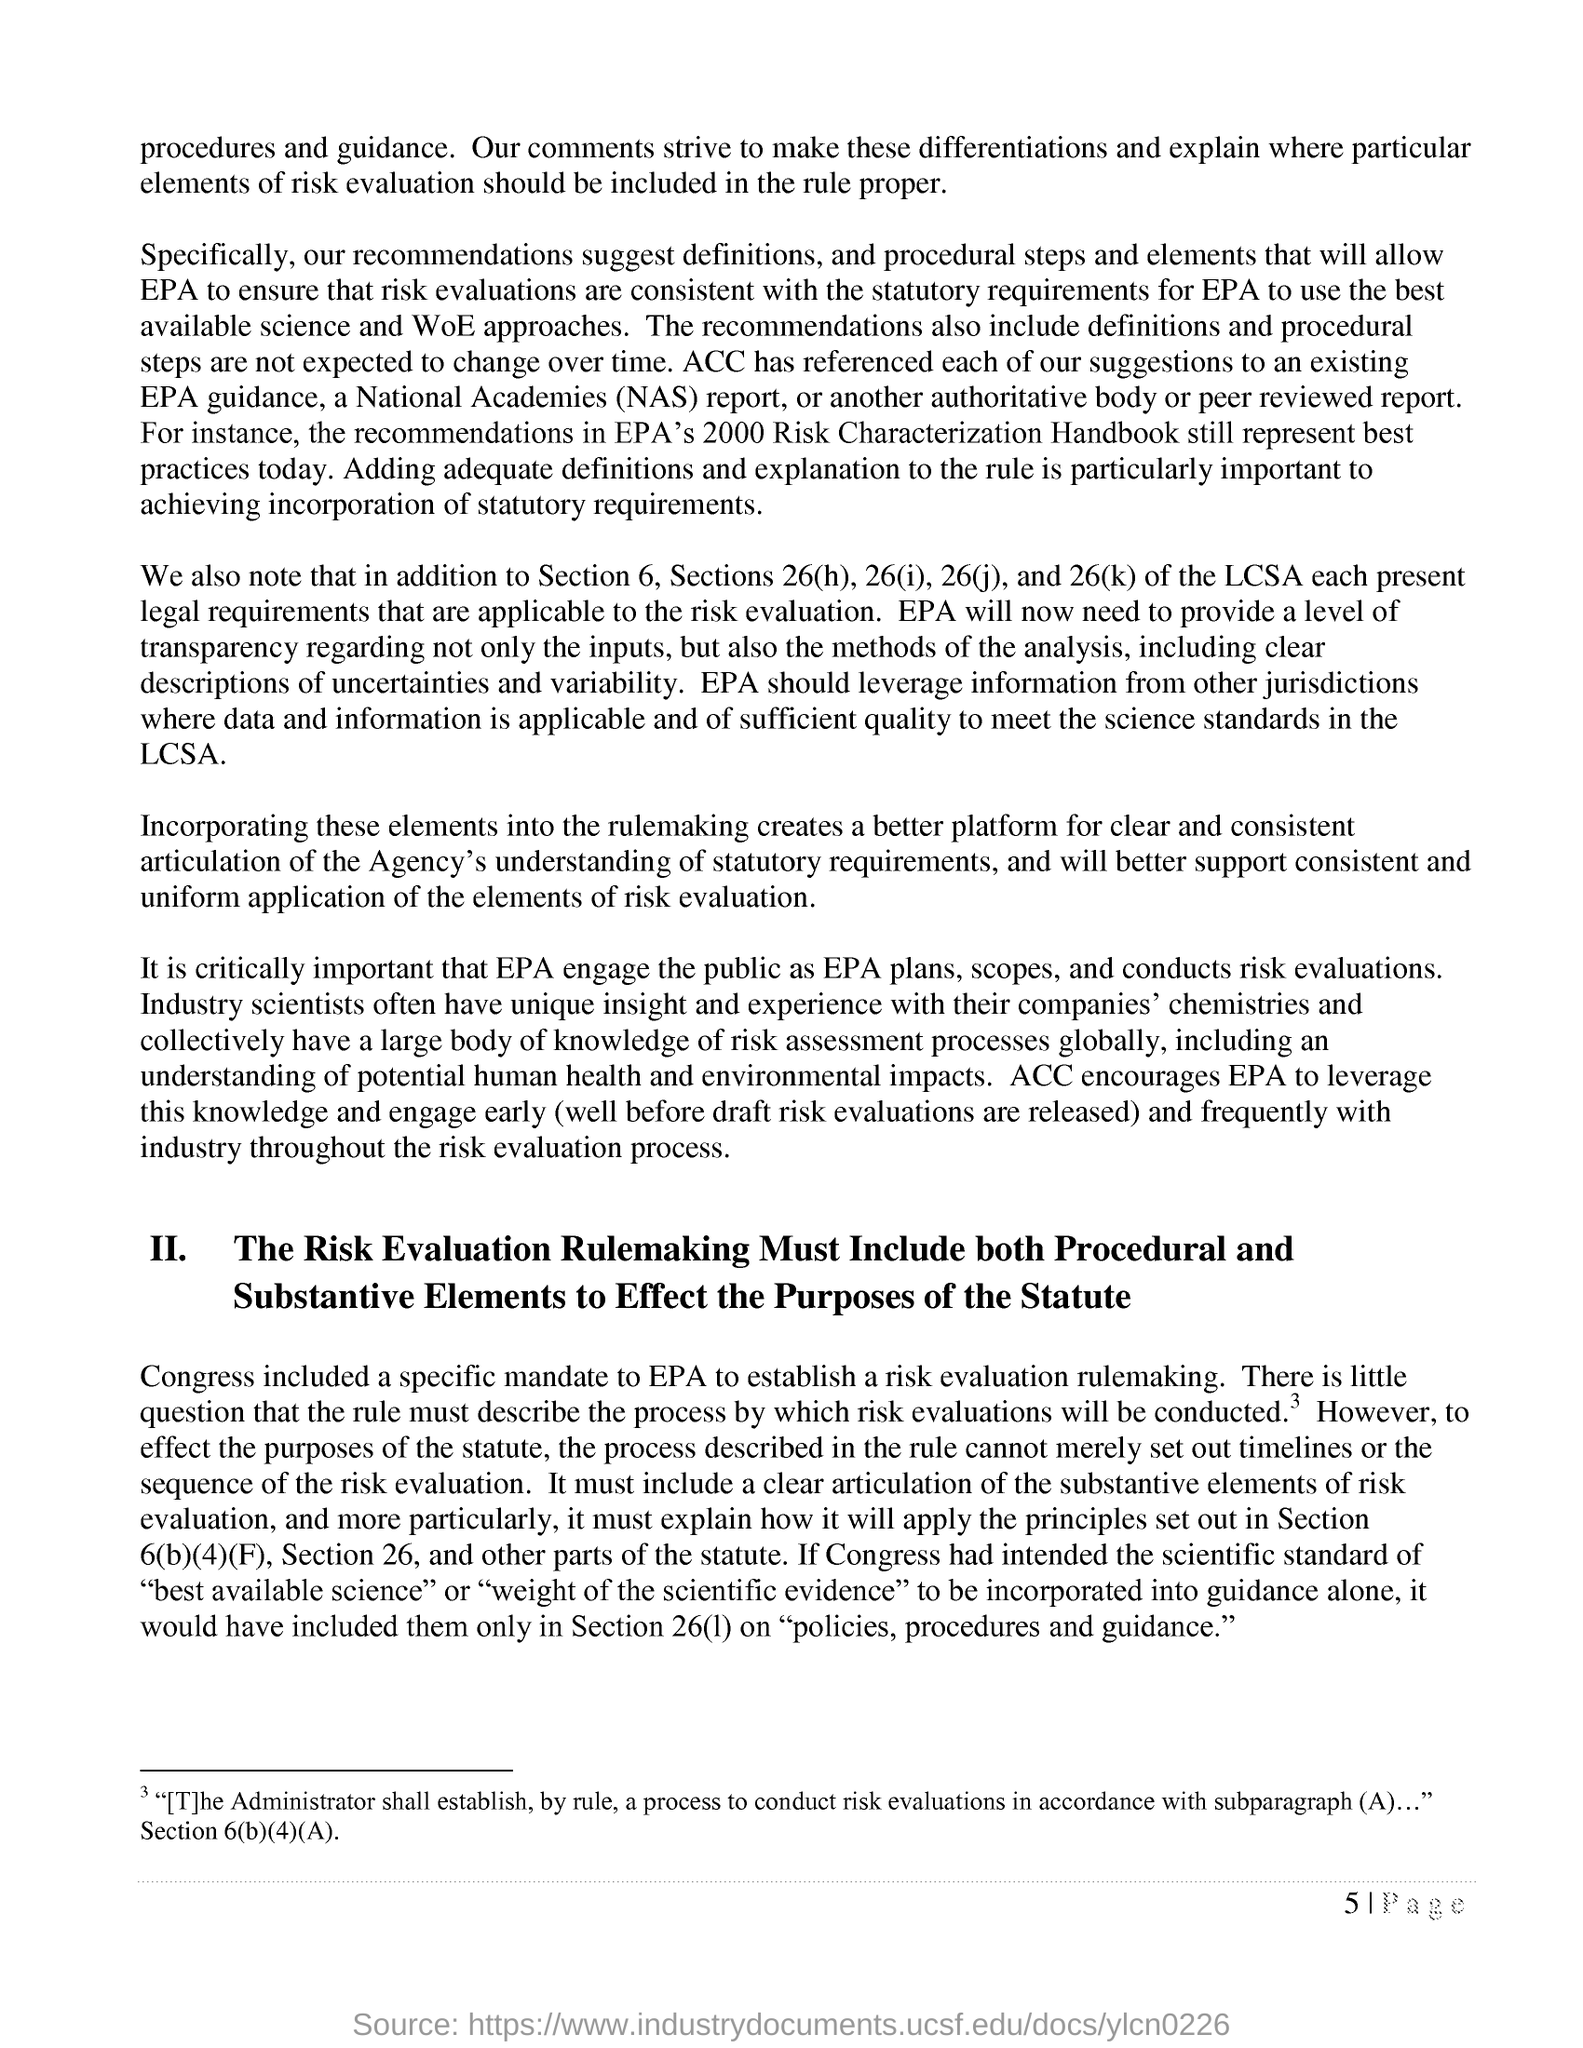List a handful of essential elements in this visual. This knowledge encourages the Environmental Protection Agency to engage with industry early and frequently throughout the risk evaluation process. What must "Risk Evaluation Rulemaking Include to Effect the Purposes of the Statute"? Both Procedural and Substantive Elements must be considered. Congress included a specific mandate to establish a risk evaluation rulemaking by the EPA. The full form of NAS is National Academies. The Risk Evaluation Rulemaking must include both procedural and substantive elements in order to achieve its intended purposes, as stated in the side heading labeled "II." 